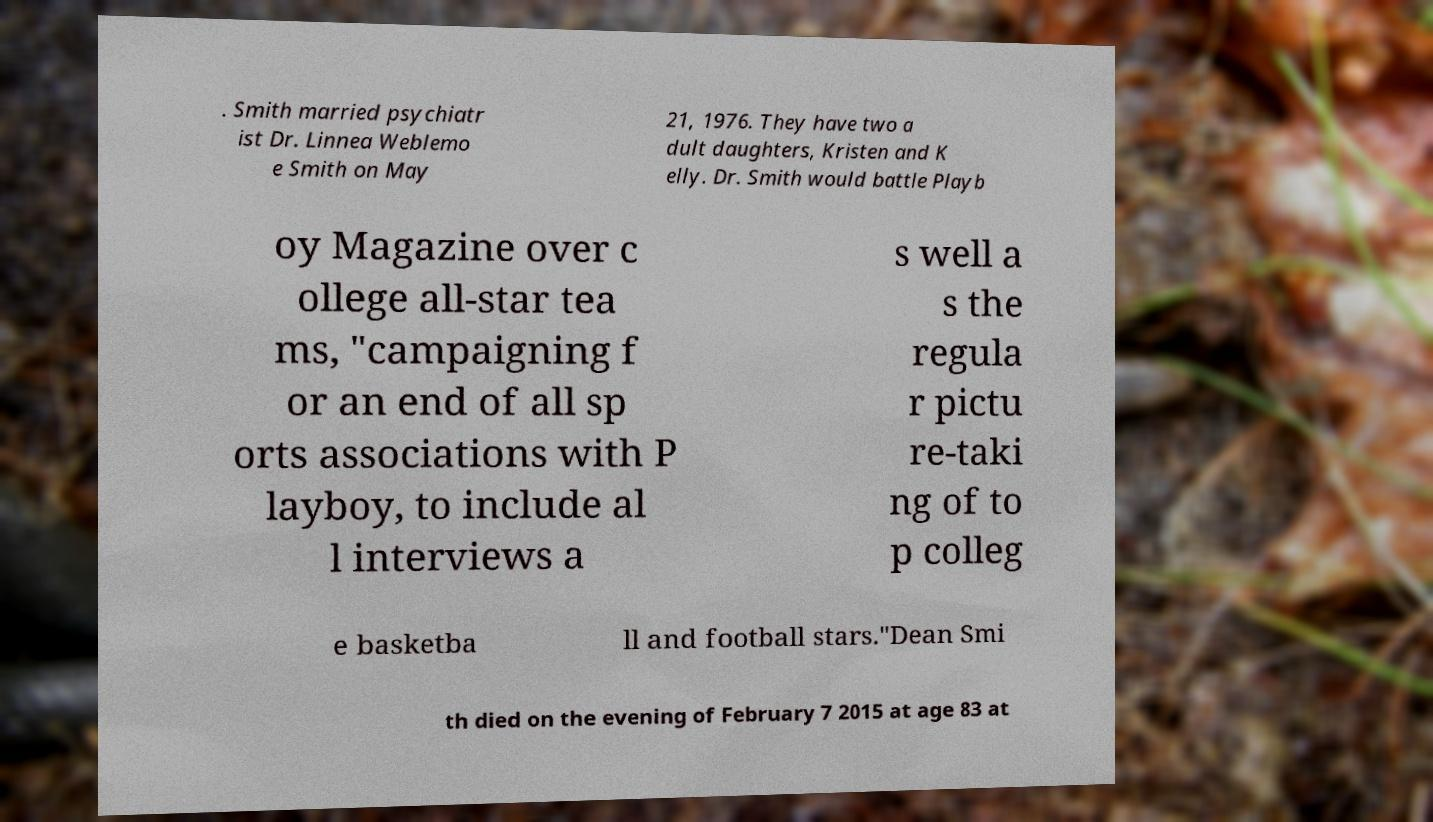Can you accurately transcribe the text from the provided image for me? . Smith married psychiatr ist Dr. Linnea Weblemo e Smith on May 21, 1976. They have two a dult daughters, Kristen and K elly. Dr. Smith would battle Playb oy Magazine over c ollege all-star tea ms, "campaigning f or an end of all sp orts associations with P layboy, to include al l interviews a s well a s the regula r pictu re-taki ng of to p colleg e basketba ll and football stars."Dean Smi th died on the evening of February 7 2015 at age 83 at 